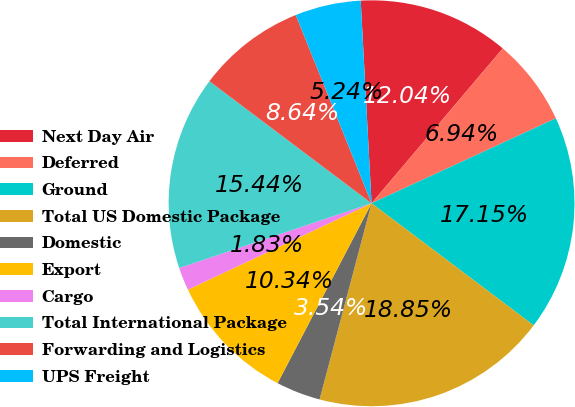Convert chart. <chart><loc_0><loc_0><loc_500><loc_500><pie_chart><fcel>Next Day Air<fcel>Deferred<fcel>Ground<fcel>Total US Domestic Package<fcel>Domestic<fcel>Export<fcel>Cargo<fcel>Total International Package<fcel>Forwarding and Logistics<fcel>UPS Freight<nl><fcel>12.04%<fcel>6.94%<fcel>17.15%<fcel>18.85%<fcel>3.54%<fcel>10.34%<fcel>1.83%<fcel>15.44%<fcel>8.64%<fcel>5.24%<nl></chart> 